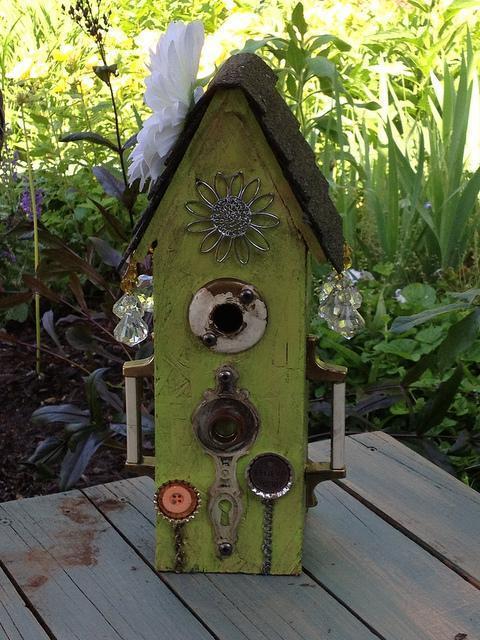How many flowers are there?
Give a very brief answer. 1. 